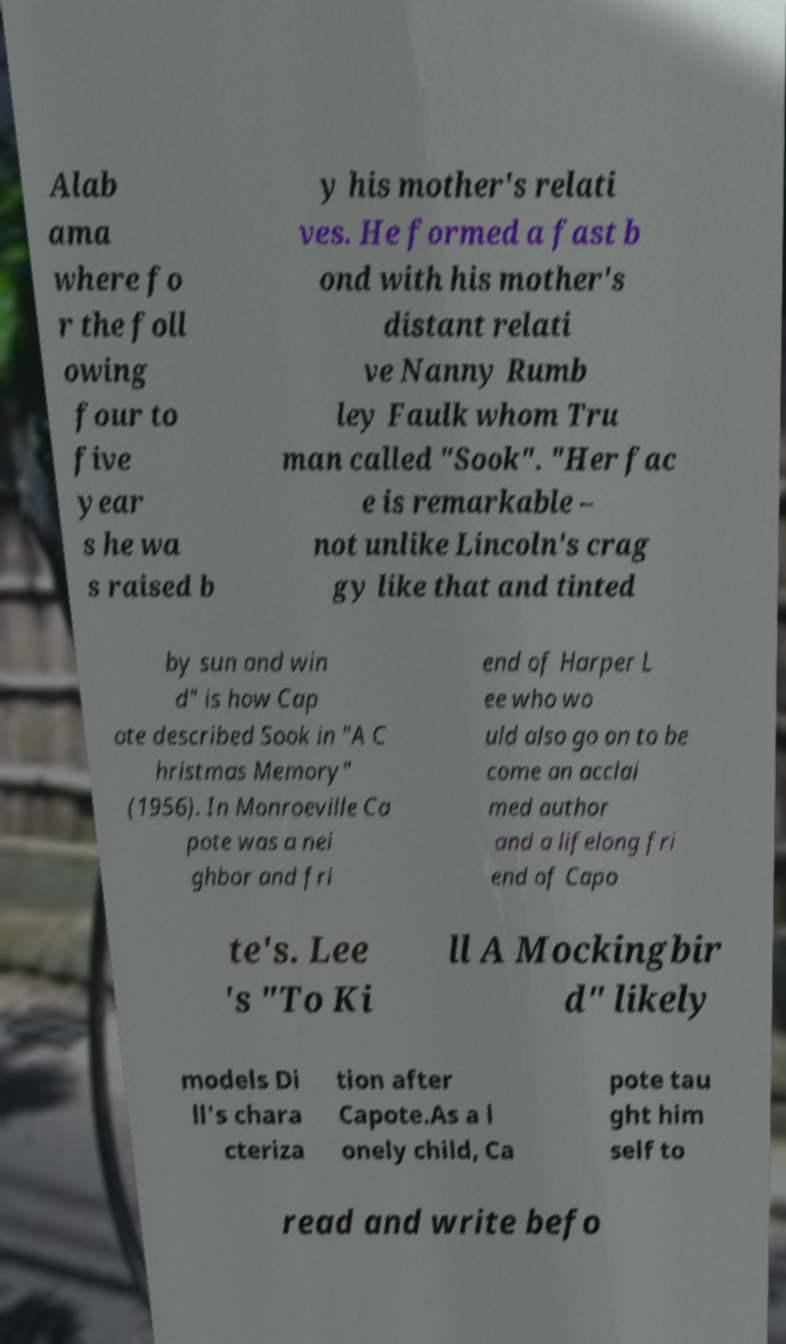There's text embedded in this image that I need extracted. Can you transcribe it verbatim? Alab ama where fo r the foll owing four to five year s he wa s raised b y his mother's relati ves. He formed a fast b ond with his mother's distant relati ve Nanny Rumb ley Faulk whom Tru man called "Sook". "Her fac e is remarkable – not unlike Lincoln's crag gy like that and tinted by sun and win d" is how Cap ote described Sook in "A C hristmas Memory" (1956). In Monroeville Ca pote was a nei ghbor and fri end of Harper L ee who wo uld also go on to be come an acclai med author and a lifelong fri end of Capo te's. Lee 's "To Ki ll A Mockingbir d" likely models Di ll's chara cteriza tion after Capote.As a l onely child, Ca pote tau ght him self to read and write befo 